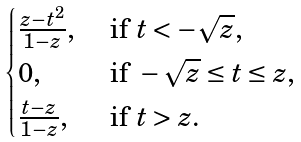<formula> <loc_0><loc_0><loc_500><loc_500>\begin{cases} \frac { z - t ^ { 2 } } { 1 - z } , & \text { if } t < - \sqrt { z } , \\ 0 , & \text { if } - \sqrt { z } \leq t \leq z , \\ \frac { t - z } { 1 - z } , & \text { if } t > z . \end{cases}</formula> 